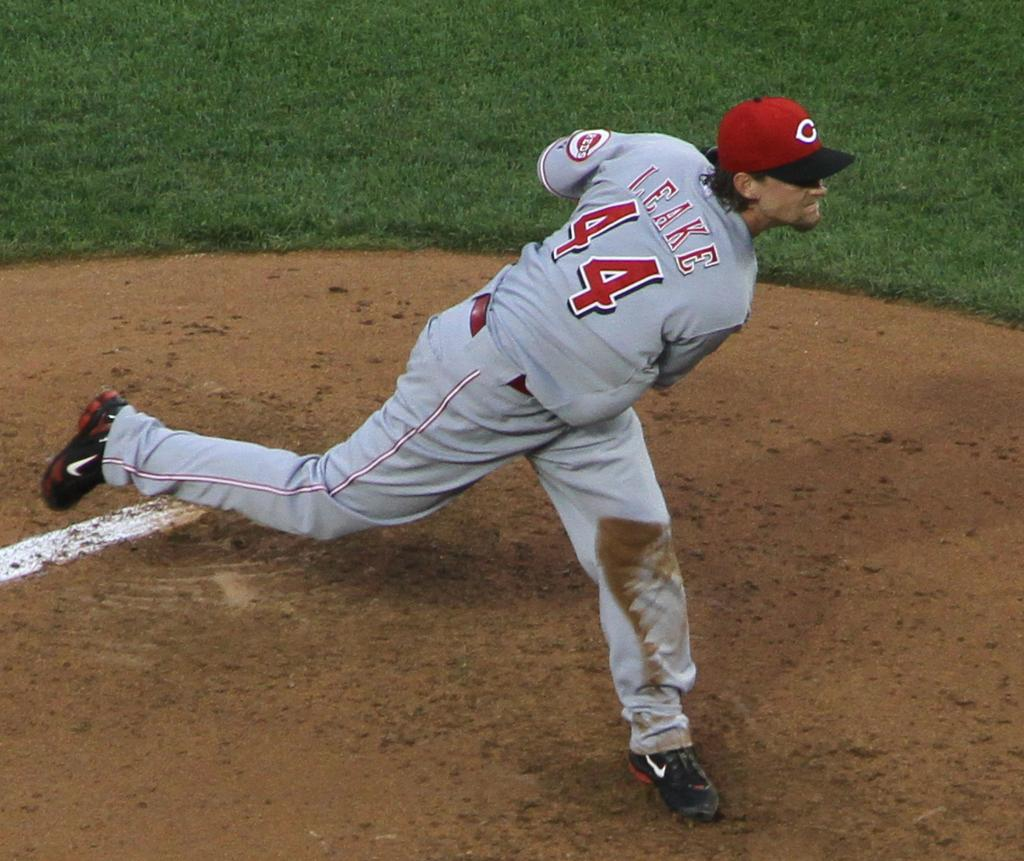<image>
Summarize the visual content of the image. Baseball player number forty-four pitching a baseball from the mound. 